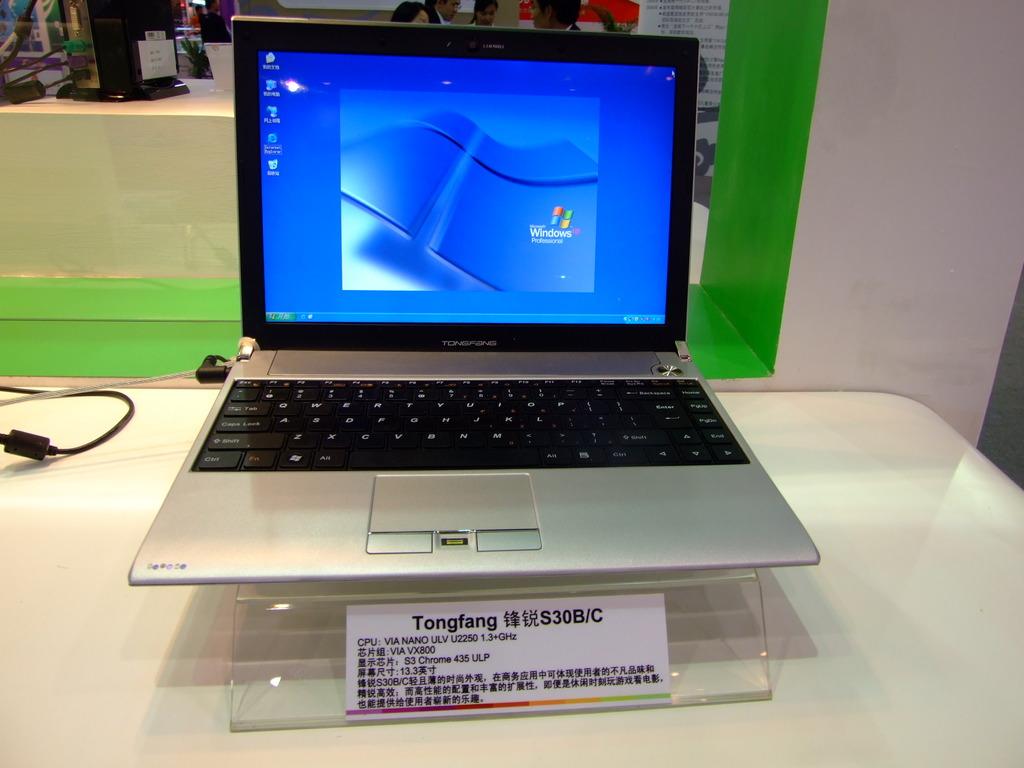What type of computer is this?
Ensure brevity in your answer.  Tongfang. Does this run windows xp?
Offer a very short reply. Yes. 